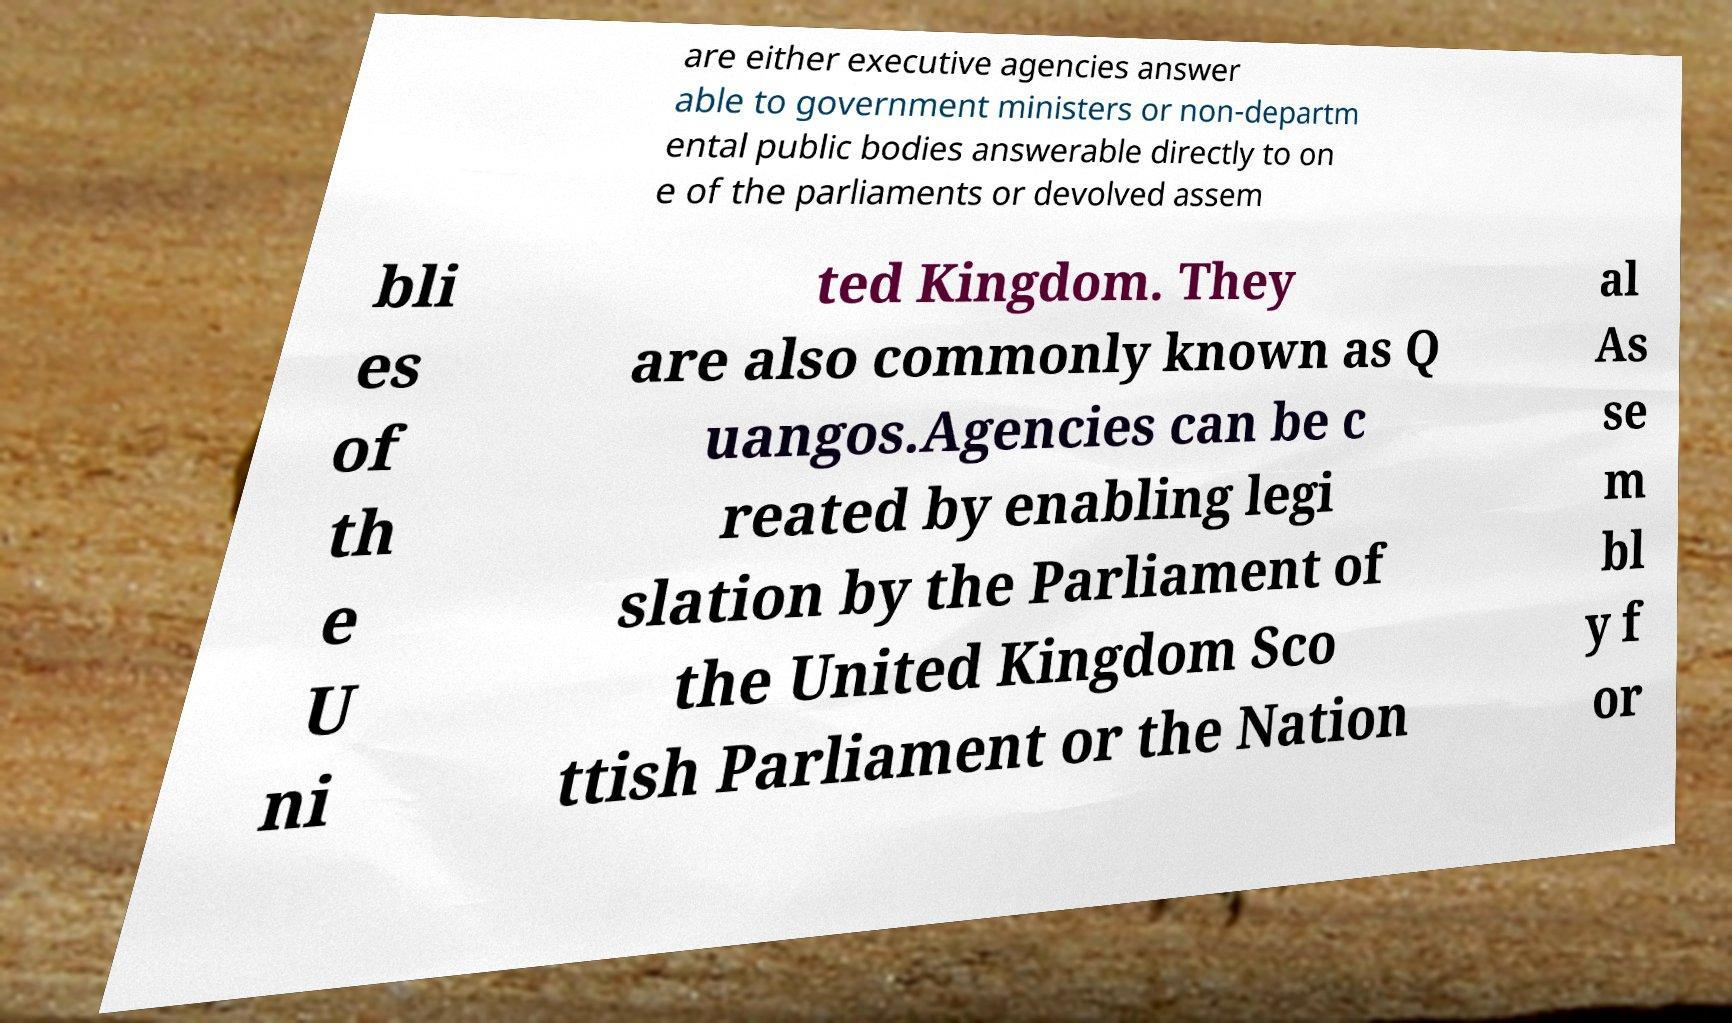There's text embedded in this image that I need extracted. Can you transcribe it verbatim? are either executive agencies answer able to government ministers or non-departm ental public bodies answerable directly to on e of the parliaments or devolved assem bli es of th e U ni ted Kingdom. They are also commonly known as Q uangos.Agencies can be c reated by enabling legi slation by the Parliament of the United Kingdom Sco ttish Parliament or the Nation al As se m bl y f or 